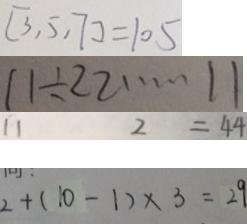Convert formula to latex. <formula><loc_0><loc_0><loc_500><loc_500>[ 3 , 5 , 7 ] = 1 0 5 
 1 1 \div 2 2 \cdots 1 1 
 1 1 2 = 4 4 
 2 + ( 1 0 - 1 ) \times 3 = 2 9</formula> 